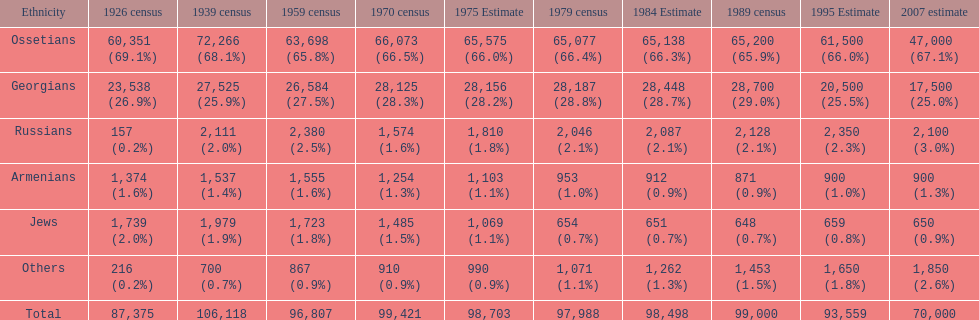What was the first census that saw a russian population of over 2,000? 1939 census. 